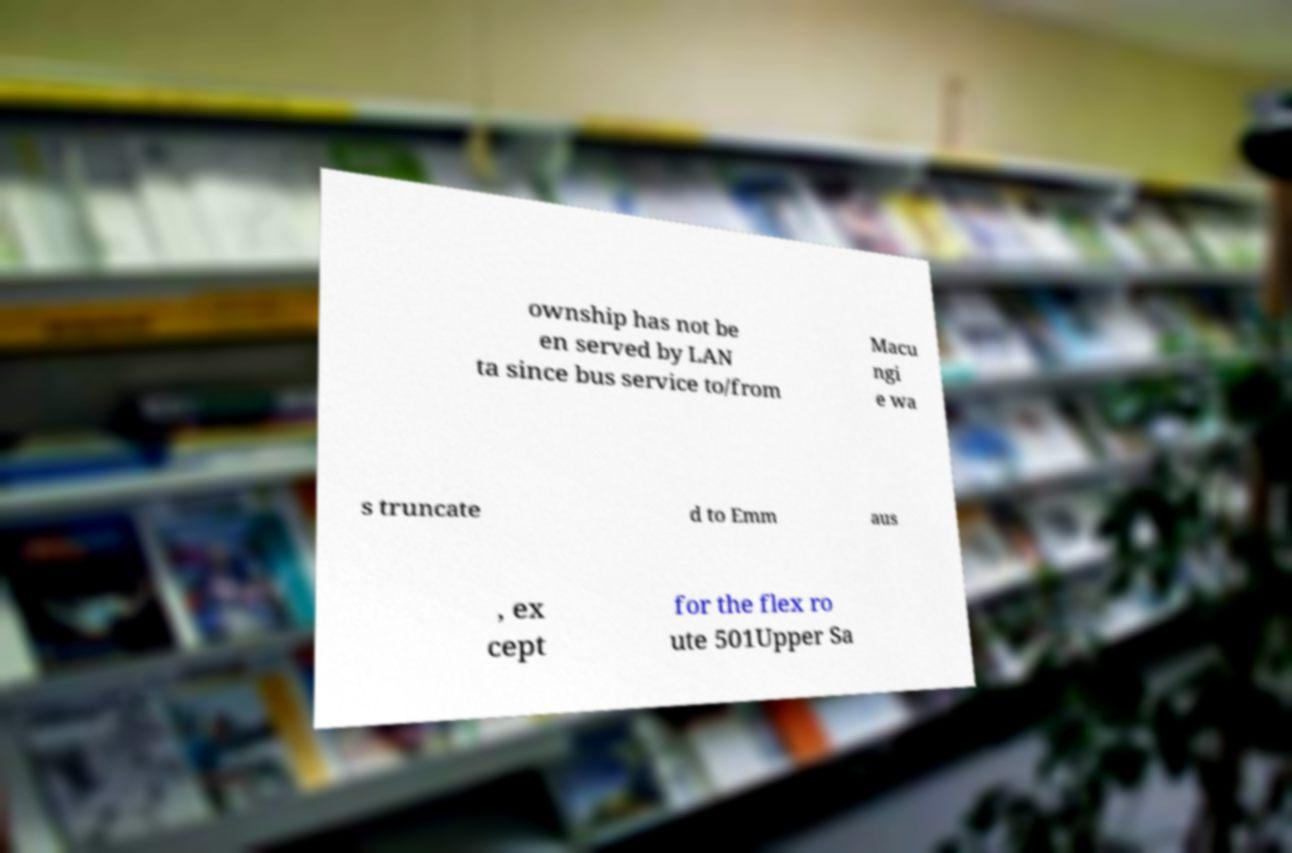There's text embedded in this image that I need extracted. Can you transcribe it verbatim? ownship has not be en served by LAN ta since bus service to/from Macu ngi e wa s truncate d to Emm aus , ex cept for the flex ro ute 501Upper Sa 